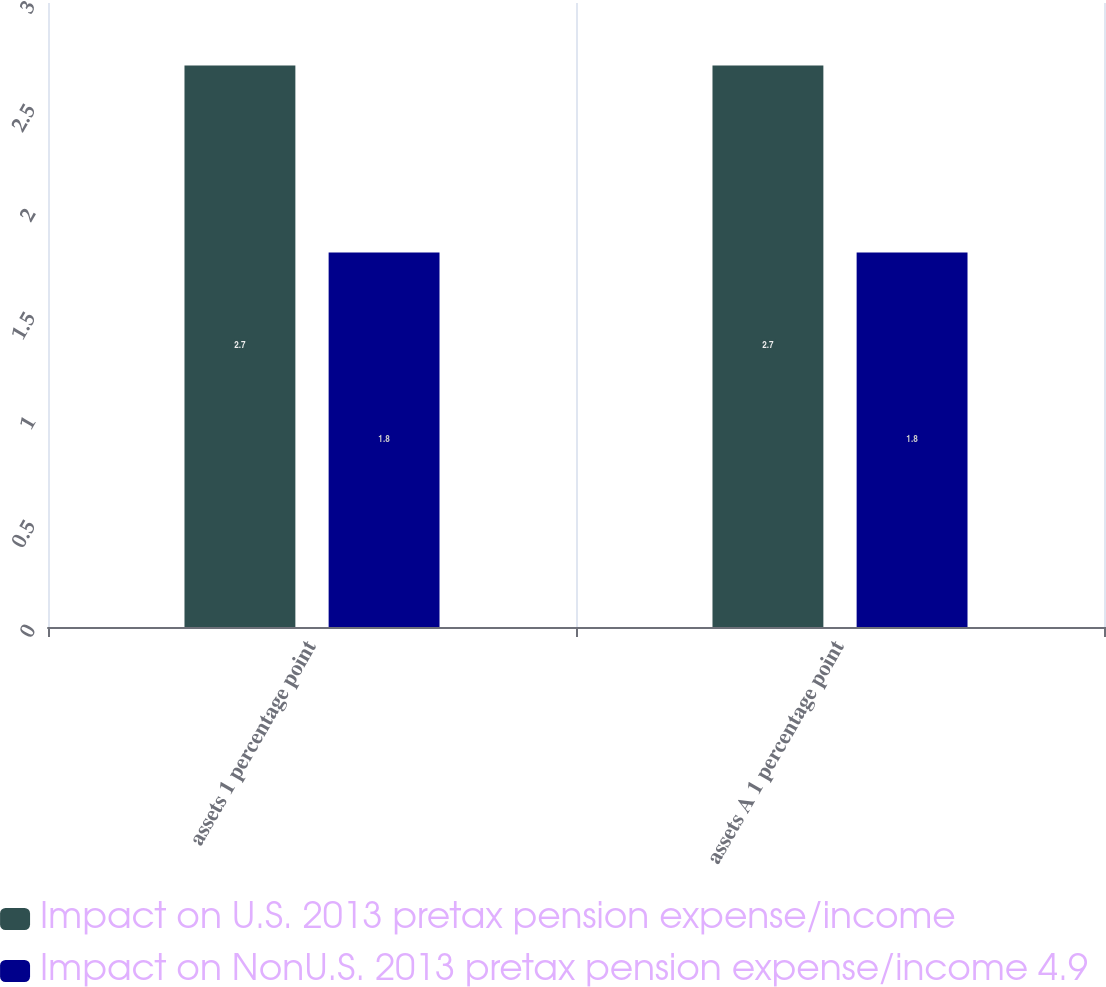<chart> <loc_0><loc_0><loc_500><loc_500><stacked_bar_chart><ecel><fcel>assets 1 percentage point<fcel>assets A 1 percentage point<nl><fcel>Impact on U.S. 2013 pretax pension expense/income<fcel>2.7<fcel>2.7<nl><fcel>Impact on NonU.S. 2013 pretax pension expense/income 4.9<fcel>1.8<fcel>1.8<nl></chart> 